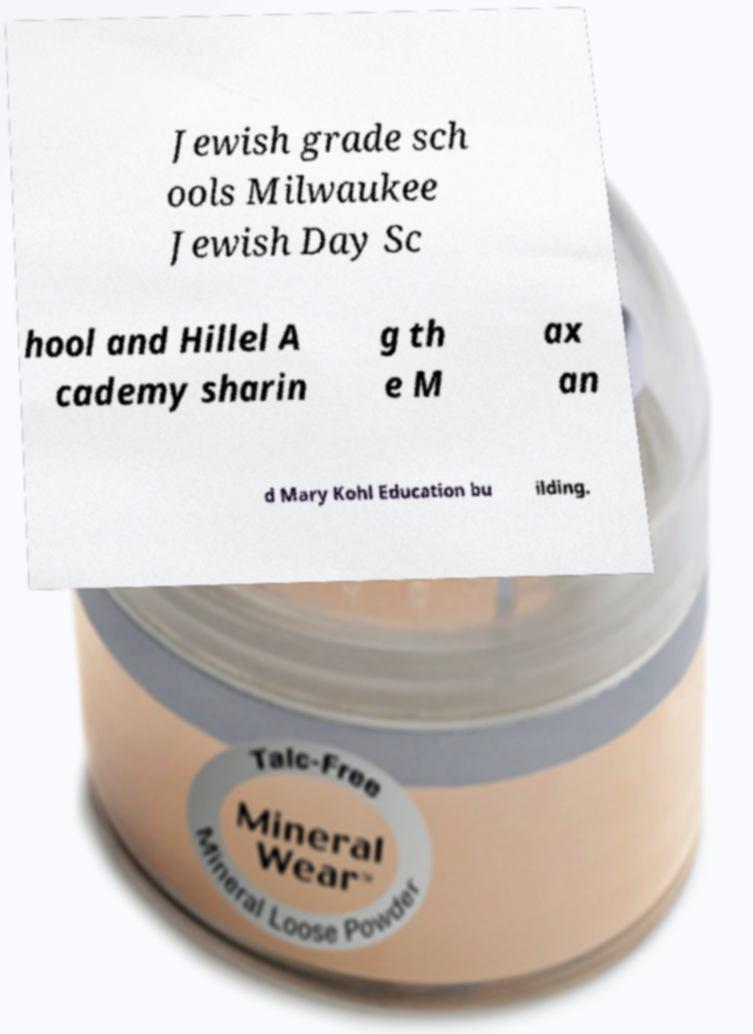Can you accurately transcribe the text from the provided image for me? Jewish grade sch ools Milwaukee Jewish Day Sc hool and Hillel A cademy sharin g th e M ax an d Mary Kohl Education bu ilding. 